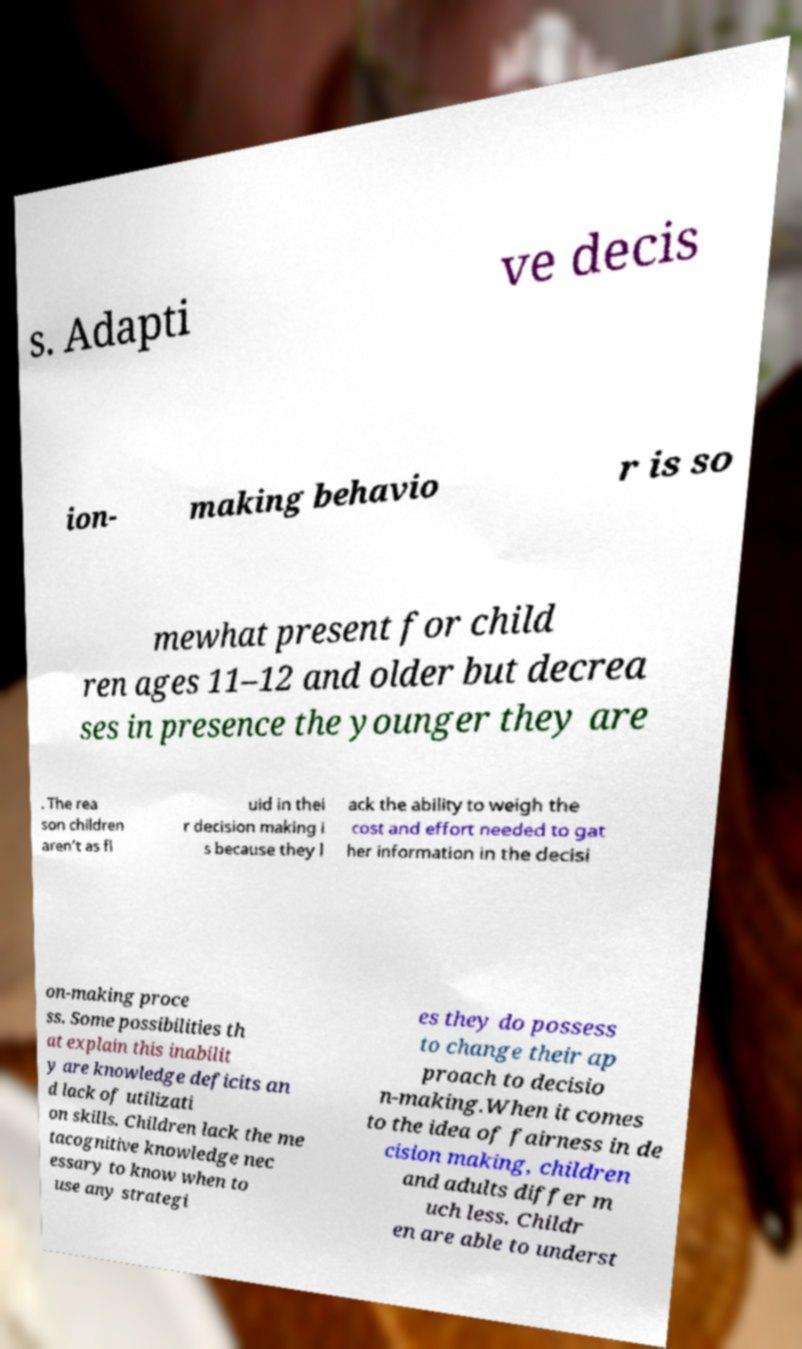Can you read and provide the text displayed in the image?This photo seems to have some interesting text. Can you extract and type it out for me? s. Adapti ve decis ion- making behavio r is so mewhat present for child ren ages 11–12 and older but decrea ses in presence the younger they are . The rea son children aren’t as fl uid in thei r decision making i s because they l ack the ability to weigh the cost and effort needed to gat her information in the decisi on-making proce ss. Some possibilities th at explain this inabilit y are knowledge deficits an d lack of utilizati on skills. Children lack the me tacognitive knowledge nec essary to know when to use any strategi es they do possess to change their ap proach to decisio n-making.When it comes to the idea of fairness in de cision making, children and adults differ m uch less. Childr en are able to underst 